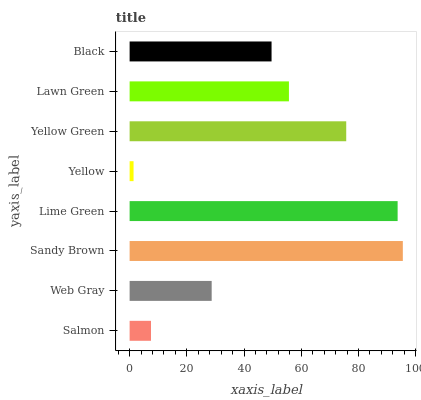Is Yellow the minimum?
Answer yes or no. Yes. Is Sandy Brown the maximum?
Answer yes or no. Yes. Is Web Gray the minimum?
Answer yes or no. No. Is Web Gray the maximum?
Answer yes or no. No. Is Web Gray greater than Salmon?
Answer yes or no. Yes. Is Salmon less than Web Gray?
Answer yes or no. Yes. Is Salmon greater than Web Gray?
Answer yes or no. No. Is Web Gray less than Salmon?
Answer yes or no. No. Is Lawn Green the high median?
Answer yes or no. Yes. Is Black the low median?
Answer yes or no. Yes. Is Lime Green the high median?
Answer yes or no. No. Is Web Gray the low median?
Answer yes or no. No. 